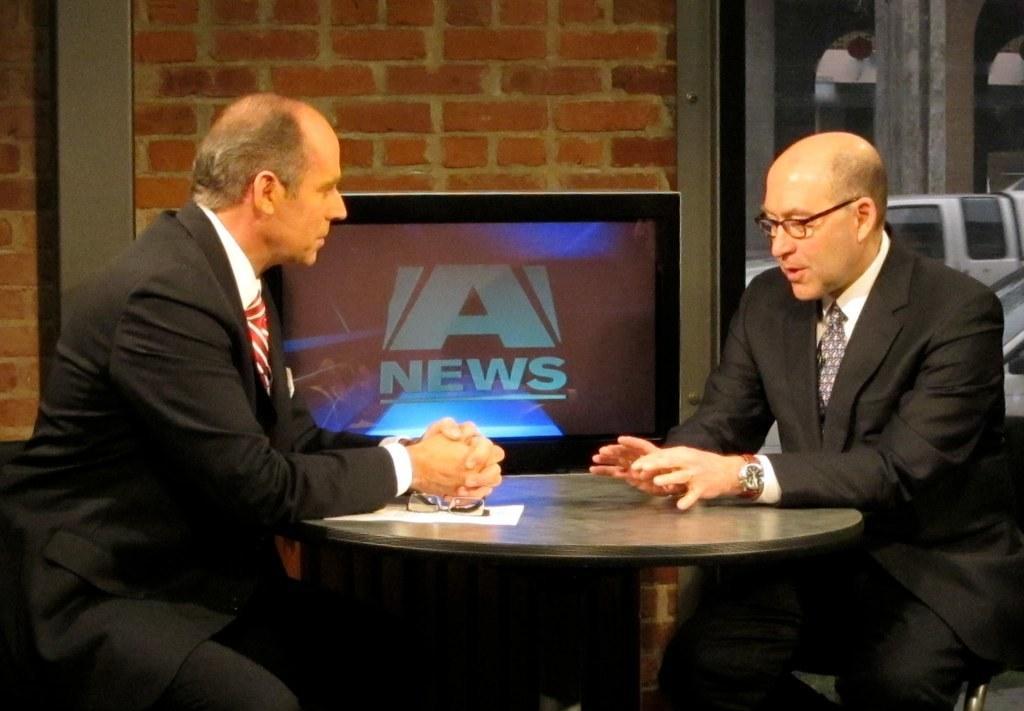Describe this image in one or two sentences. To the left side there is a man with black jacket, white shirt and red tie. In front of him there is another man with black jacket, white shirt and blue tie is sitting. In between them there is a table with paper and spectacles on it. In middle there is a TV screen attached to the brick wall. 